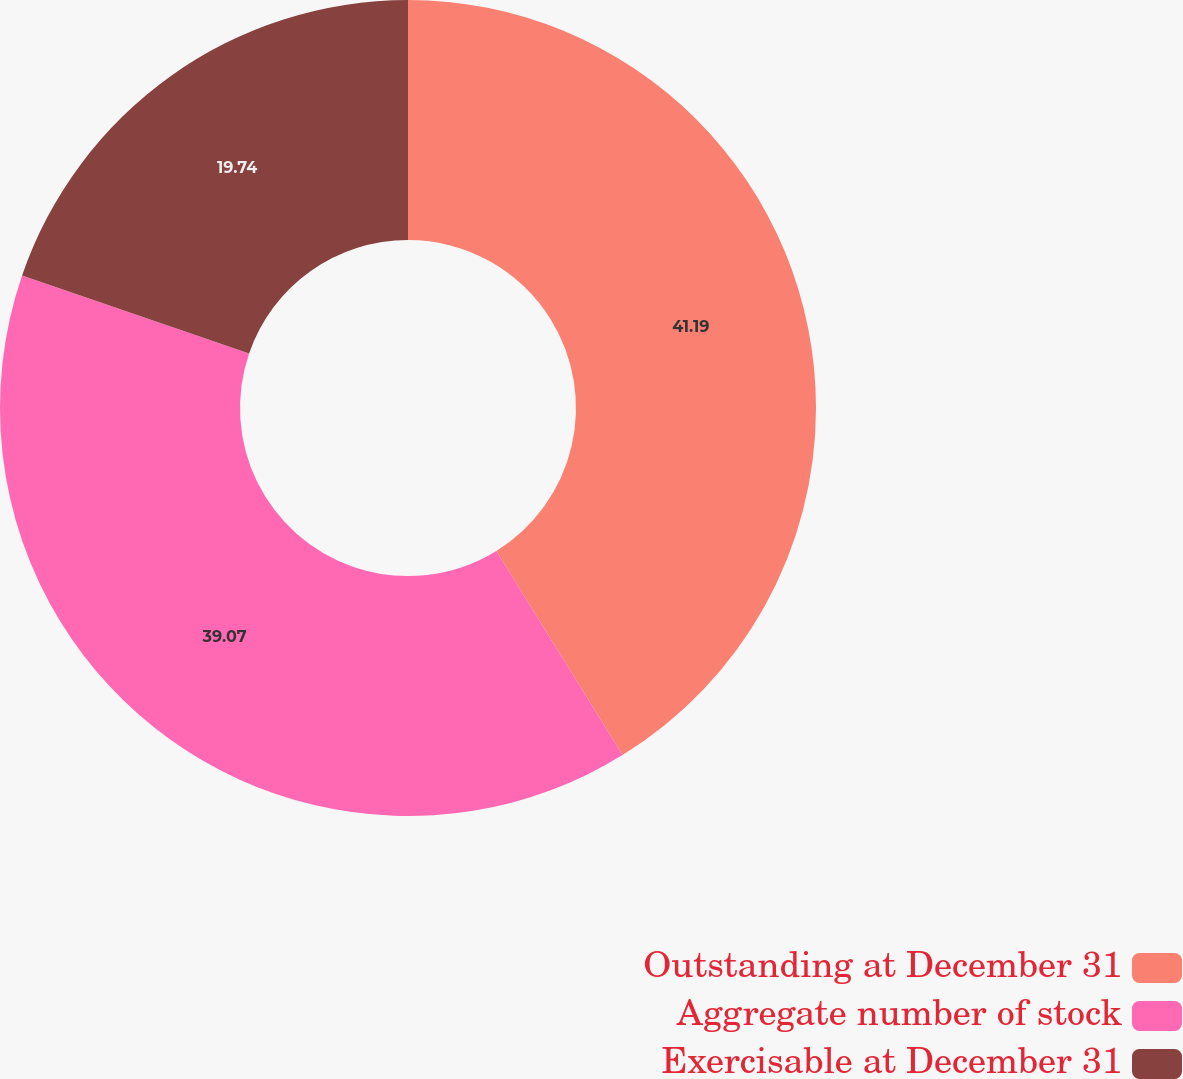Convert chart to OTSL. <chart><loc_0><loc_0><loc_500><loc_500><pie_chart><fcel>Outstanding at December 31<fcel>Aggregate number of stock<fcel>Exercisable at December 31<nl><fcel>41.19%<fcel>39.07%<fcel>19.74%<nl></chart> 